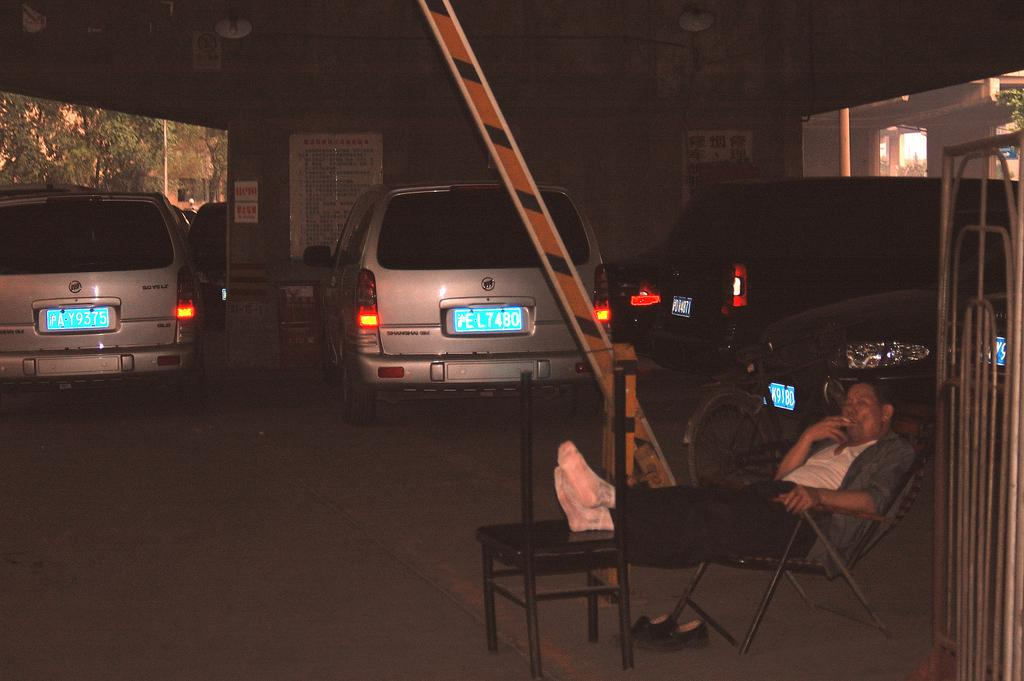Who is present in the image? There is a man in the image. What is the man doing in the image? The man is sitting on a chair. How is the man positioned on the chair? The man's legs are on the chair. What can be seen in the distance in the image? There are cars and a building visible in the background of the image. What type of dock can be seen in the bedroom of the image? There is no dock or bedroom present in the image; it features a man sitting on a chair with a background of cars and a building. 